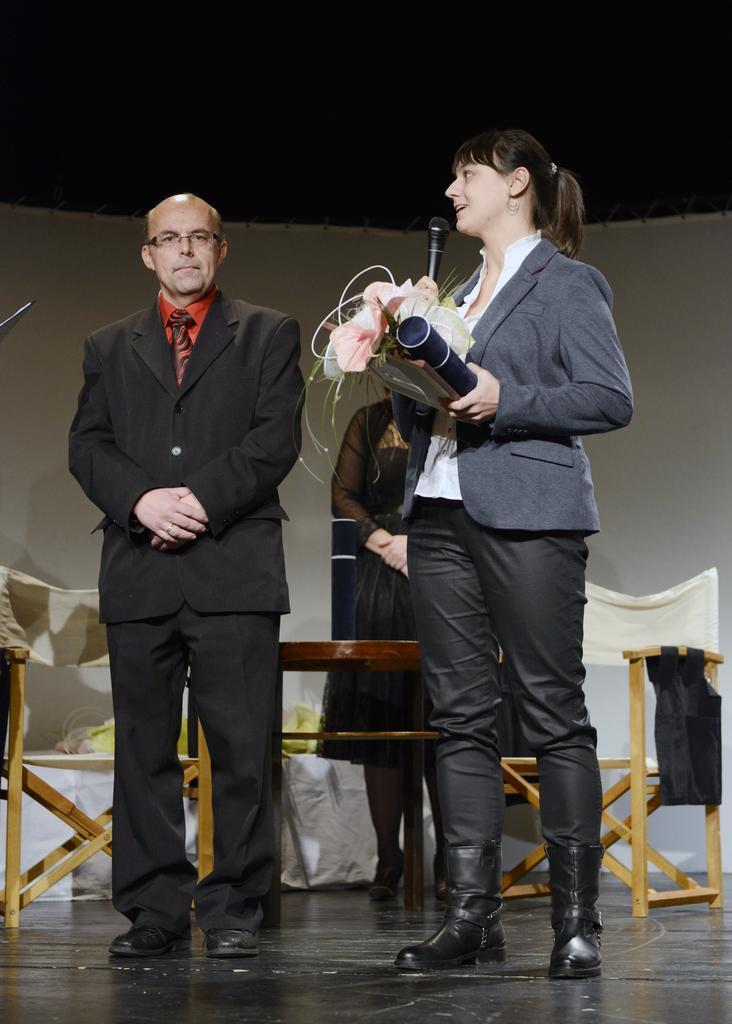Can you describe this image briefly? In this image I see a man who is wearing suit and I see a woman over here who is holding a mic and other things in hands and I see the floor. In the background I see another person over here and I see the chairs and I see that this woman is wearing black dress and this woman is wearing white, grey and black dress. 